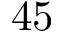Convert formula to latex. <formula><loc_0><loc_0><loc_500><loc_500>4 5</formula> 